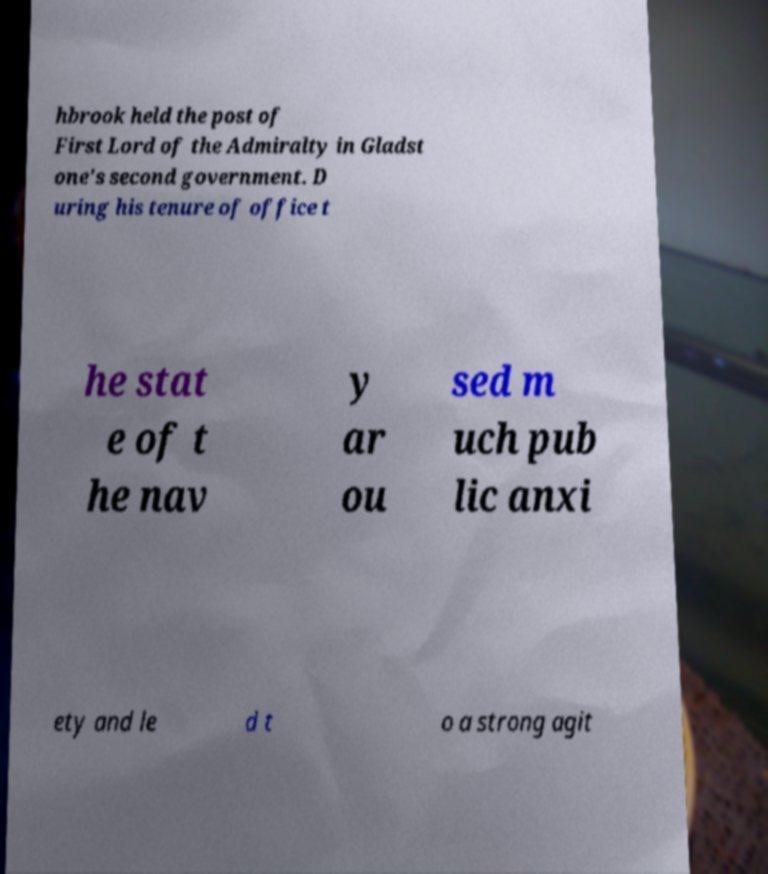Could you assist in decoding the text presented in this image and type it out clearly? hbrook held the post of First Lord of the Admiralty in Gladst one's second government. D uring his tenure of office t he stat e of t he nav y ar ou sed m uch pub lic anxi ety and le d t o a strong agit 